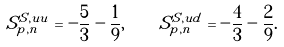<formula> <loc_0><loc_0><loc_500><loc_500>S ^ { S , u u } _ { p , n } = - \frac { 5 } { 3 } - \frac { 1 } { 9 } , \quad S ^ { S , u d } _ { p , n } = - \frac { 4 } { 3 } - \frac { 2 } { 9 } .</formula> 